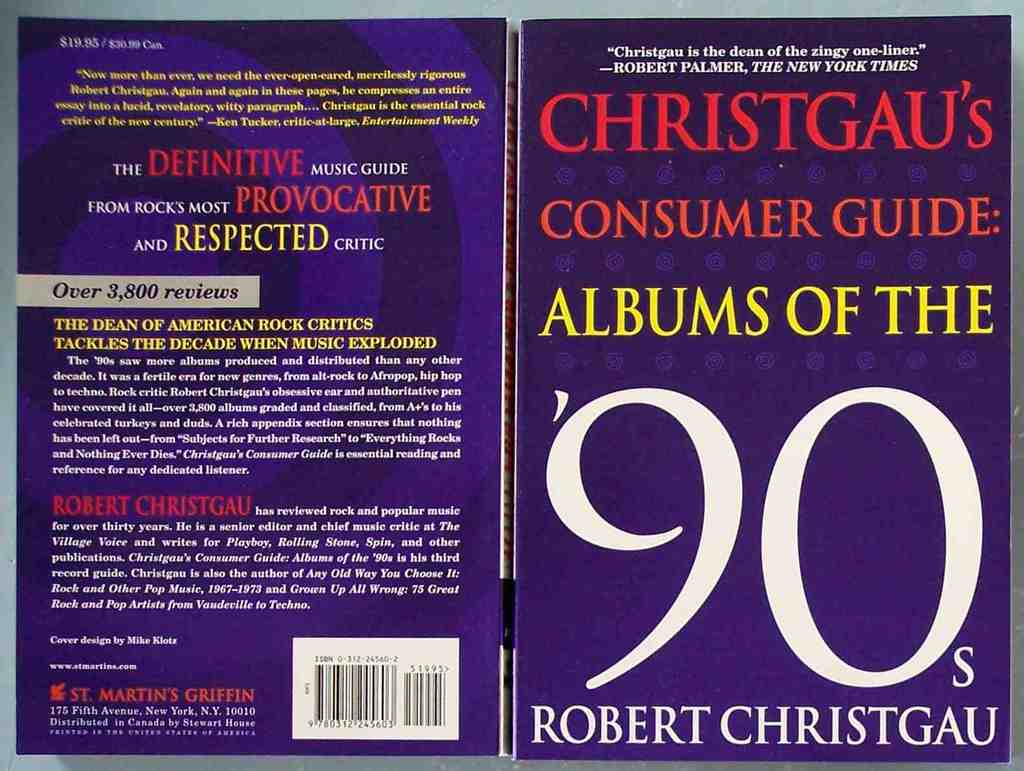Can you tell me more about the author, Robert Christgau, mentioned on this book cover? Robert Christgau, known as the 'Dean of American Rock Critics,' has been a prominent voice in music criticism for over three decades. Starting his career in the 1960s, Christgau is renowned for his sharp, concise reviews, often encapsulating complex opinions in witty one-liners. His work spans several major publications and he is particularly noted for creating the 'Consumer Guide' format in which albums are quickly reviewed in a succinct and direct style. This guide on 90s albums features his in-depth knowledge and candid opinions about a transformative era in music history. 